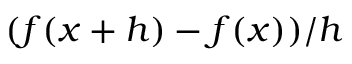Convert formula to latex. <formula><loc_0><loc_0><loc_500><loc_500>( f ( x + h ) - f ( x ) ) / h</formula> 